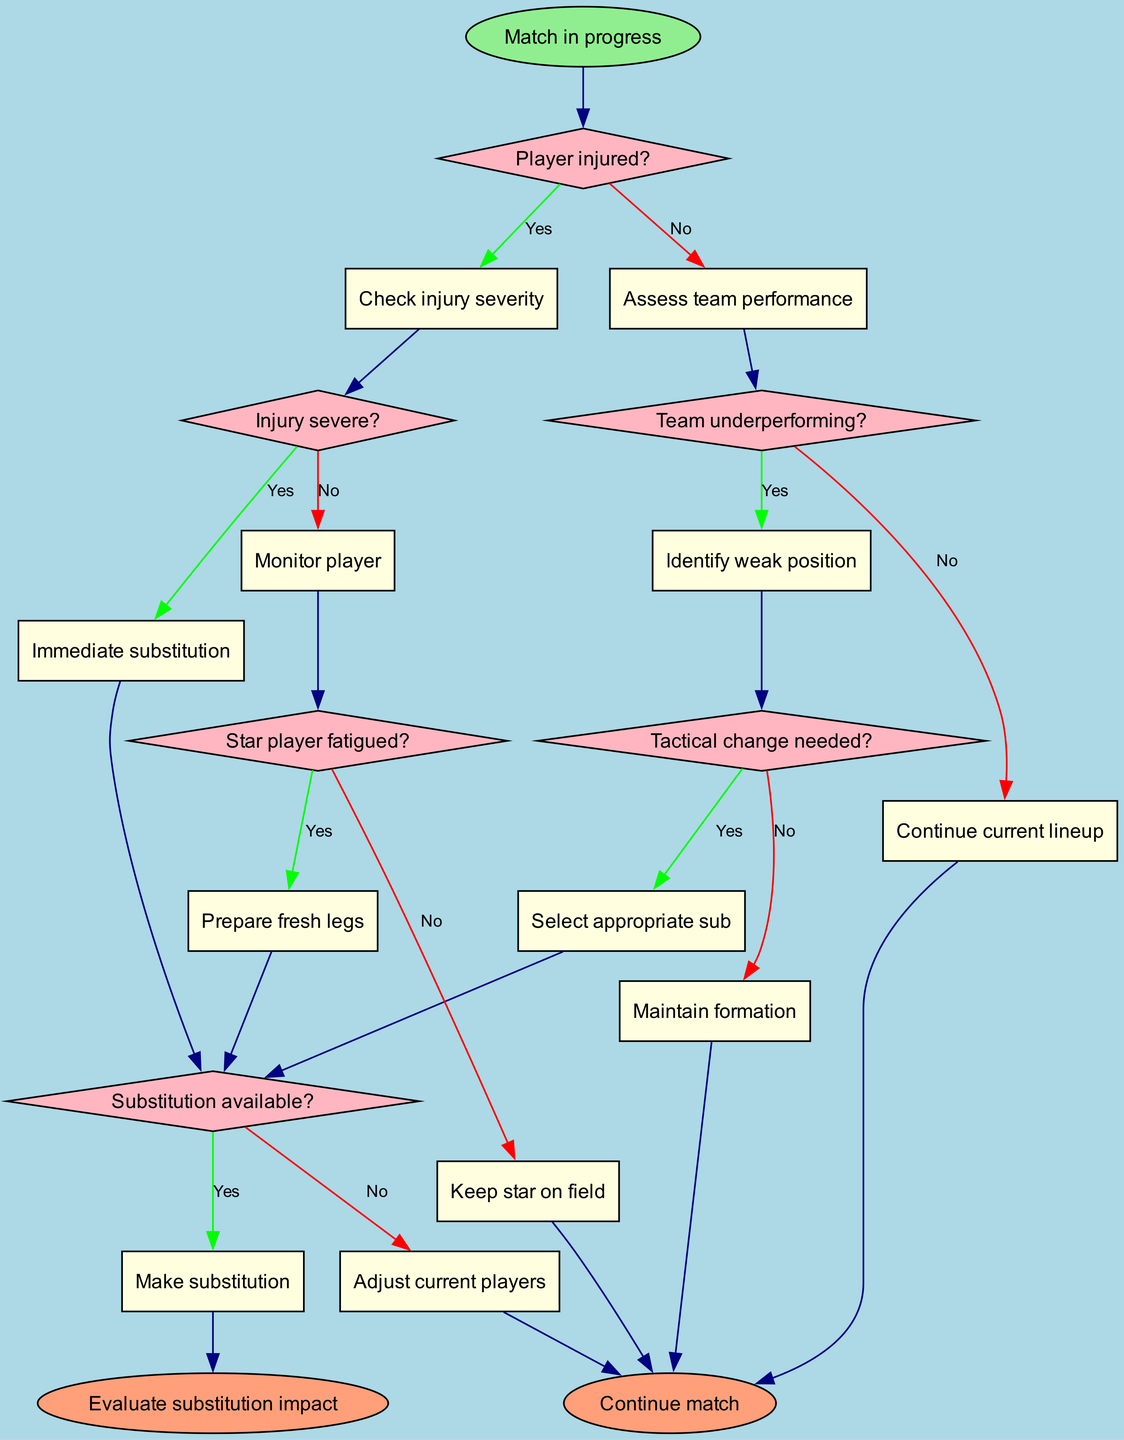What is the starting point of the flowchart? The flowchart begins with the node labeled "Match in progress," indicating that the decision-making process starts during an active match.
Answer: Match in progress How many decision points are there in the flowchart? The flowchart contains six decision points, each corresponding to different conditions that affect player substitution.
Answer: 6 What is the first decision condition in the flowchart? The first decision node asks, "Player injured?" which is the initial condition to assess before making a substitution.
Answer: Player injured? What happens if the team is underperforming? If the team is underperforming (answering "Yes" to the condition), the next action is to "Identify weak position," determining where a new player may be needed.
Answer: Identify weak position If a star player is fatigued, what is the next action? Should the condition "Star player fatigued?" be answered with "Yes," the flowchart directs to "Prepare fresh legs," indicating that a substitution needs to be arranged.
Answer: Prepare fresh legs What is the outcome if no substitution is available? If no substitution is available, the flowchart leads to "Adjust current players," indicating that the coach needs to modify the current players' roles instead of bringing in a new player.
Answer: Adjust current players Which node indicates the evaluation after making substitutions? The node labeled "Evaluate substitution impact" represents the assessment of how substitutions affected the match performance after they are made.
Answer: Evaluate substitution impact What condition follows after the decision about player injury severity? After determining injury severity, the flowchart leads to the decision node that asks if the injury is severe, thus directing the next action based on this evaluation.
Answer: Injury severe? What should a coach do if no tactical change is needed? If the condition "Tactical change needed?" is answered with "No", the coach should "Maintain formation," thereby keeping the existing gameplay strategy intact.
Answer: Maintain formation 